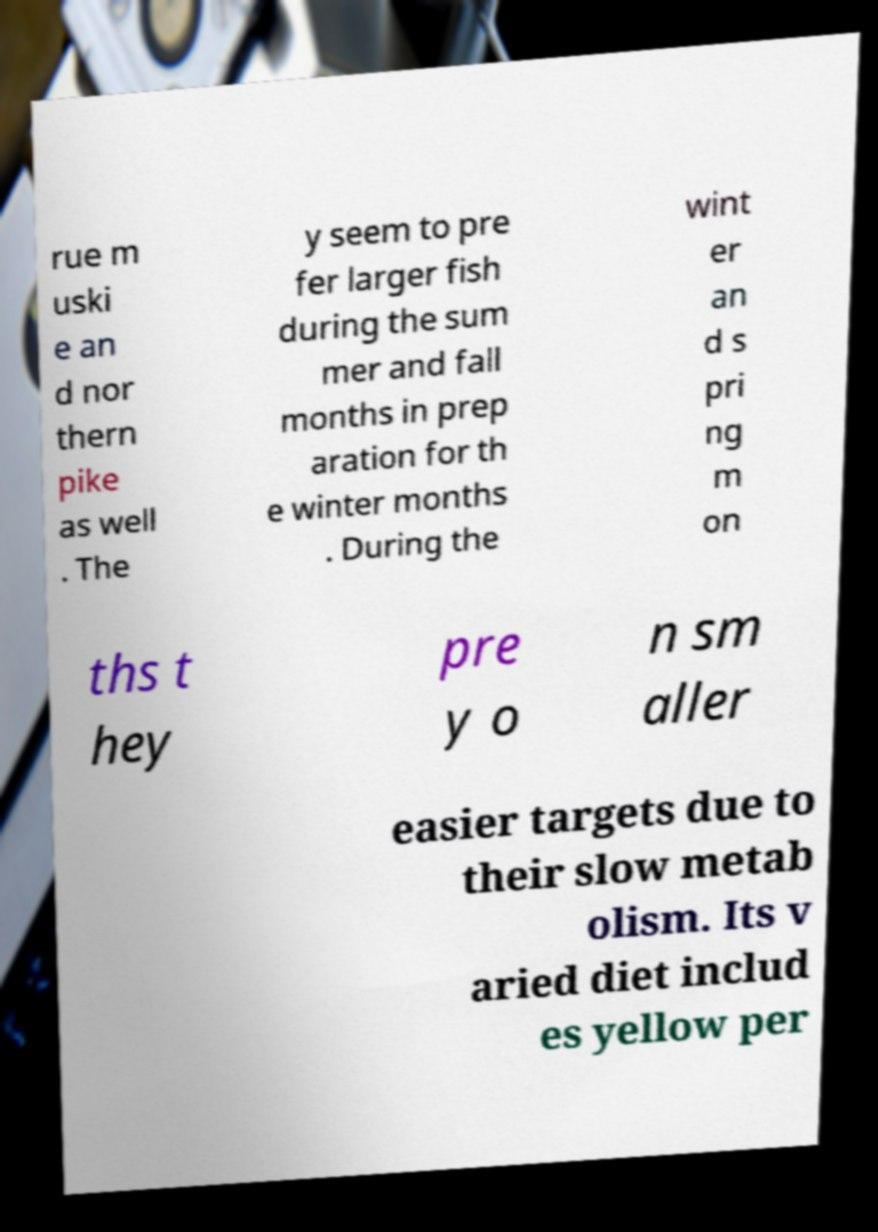Can you accurately transcribe the text from the provided image for me? rue m uski e an d nor thern pike as well . The y seem to pre fer larger fish during the sum mer and fall months in prep aration for th e winter months . During the wint er an d s pri ng m on ths t hey pre y o n sm aller easier targets due to their slow metab olism. Its v aried diet includ es yellow per 